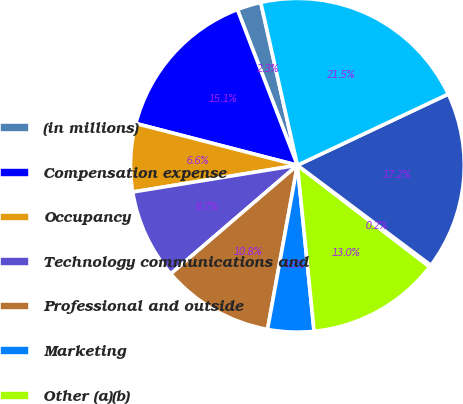Convert chart. <chart><loc_0><loc_0><loc_500><loc_500><pie_chart><fcel>(in millions)<fcel>Compensation expense<fcel>Occupancy<fcel>Technology communications and<fcel>Professional and outside<fcel>Marketing<fcel>Other (a)(b)<fcel>Amortization of intangibles<fcel>Total noncompensation expense<fcel>Total noninterest expense<nl><fcel>2.33%<fcel>15.12%<fcel>6.59%<fcel>8.72%<fcel>10.85%<fcel>4.46%<fcel>12.98%<fcel>0.19%<fcel>17.25%<fcel>21.51%<nl></chart> 